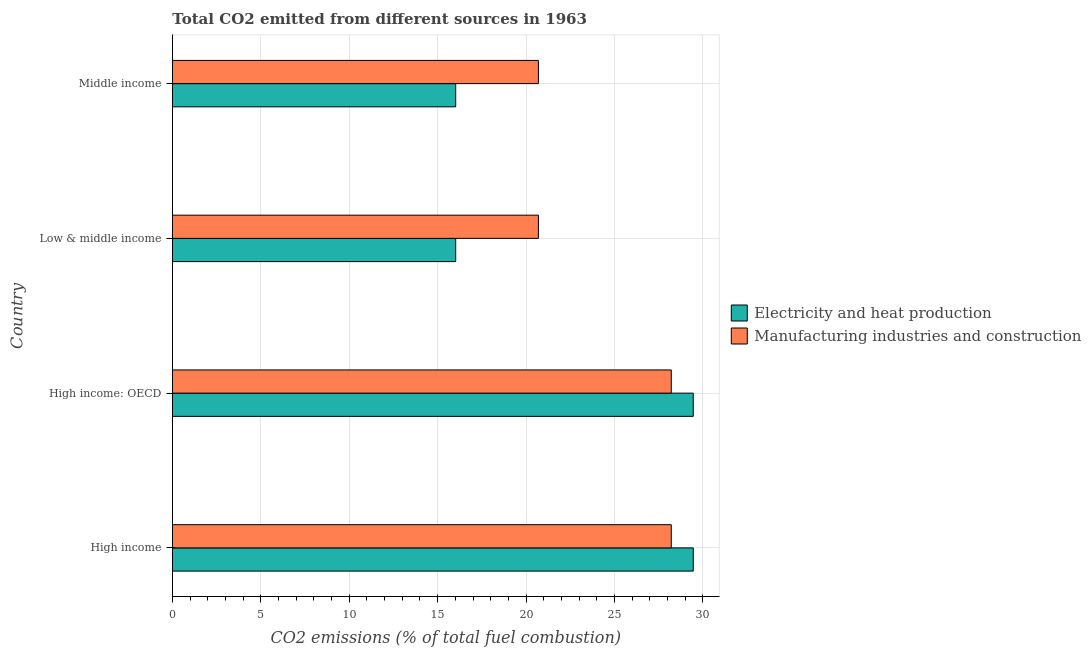How many different coloured bars are there?
Offer a very short reply. 2. How many groups of bars are there?
Your answer should be compact. 4. What is the label of the 1st group of bars from the top?
Ensure brevity in your answer.  Middle income. In how many cases, is the number of bars for a given country not equal to the number of legend labels?
Your answer should be compact. 0. What is the co2 emissions due to electricity and heat production in High income: OECD?
Offer a terse response. 29.45. Across all countries, what is the maximum co2 emissions due to manufacturing industries?
Your answer should be very brief. 28.21. Across all countries, what is the minimum co2 emissions due to electricity and heat production?
Offer a terse response. 16.02. In which country was the co2 emissions due to electricity and heat production maximum?
Provide a short and direct response. High income. What is the total co2 emissions due to manufacturing industries in the graph?
Your answer should be very brief. 97.81. What is the difference between the co2 emissions due to electricity and heat production in High income and that in Middle income?
Offer a terse response. 13.43. What is the difference between the co2 emissions due to manufacturing industries in Middle income and the co2 emissions due to electricity and heat production in Low & middle income?
Make the answer very short. 4.68. What is the average co2 emissions due to electricity and heat production per country?
Give a very brief answer. 22.73. What is the difference between the co2 emissions due to manufacturing industries and co2 emissions due to electricity and heat production in Low & middle income?
Provide a short and direct response. 4.68. What is the ratio of the co2 emissions due to electricity and heat production in High income to that in High income: OECD?
Your answer should be very brief. 1. Is the co2 emissions due to manufacturing industries in High income less than that in Low & middle income?
Offer a terse response. No. Is the difference between the co2 emissions due to electricity and heat production in High income: OECD and Middle income greater than the difference between the co2 emissions due to manufacturing industries in High income: OECD and Middle income?
Ensure brevity in your answer.  Yes. What is the difference between the highest and the second highest co2 emissions due to electricity and heat production?
Your answer should be very brief. 0. What is the difference between the highest and the lowest co2 emissions due to manufacturing industries?
Give a very brief answer. 7.51. In how many countries, is the co2 emissions due to electricity and heat production greater than the average co2 emissions due to electricity and heat production taken over all countries?
Ensure brevity in your answer.  2. What does the 1st bar from the top in Low & middle income represents?
Ensure brevity in your answer.  Manufacturing industries and construction. What does the 2nd bar from the bottom in High income: OECD represents?
Your answer should be compact. Manufacturing industries and construction. How many bars are there?
Make the answer very short. 8. How many countries are there in the graph?
Your response must be concise. 4. Are the values on the major ticks of X-axis written in scientific E-notation?
Your response must be concise. No. Does the graph contain any zero values?
Your response must be concise. No. How are the legend labels stacked?
Your answer should be compact. Vertical. What is the title of the graph?
Your answer should be very brief. Total CO2 emitted from different sources in 1963. What is the label or title of the X-axis?
Your response must be concise. CO2 emissions (% of total fuel combustion). What is the CO2 emissions (% of total fuel combustion) in Electricity and heat production in High income?
Your response must be concise. 29.45. What is the CO2 emissions (% of total fuel combustion) of Manufacturing industries and construction in High income?
Provide a short and direct response. 28.21. What is the CO2 emissions (% of total fuel combustion) of Electricity and heat production in High income: OECD?
Offer a very short reply. 29.45. What is the CO2 emissions (% of total fuel combustion) of Manufacturing industries and construction in High income: OECD?
Offer a terse response. 28.21. What is the CO2 emissions (% of total fuel combustion) in Electricity and heat production in Low & middle income?
Offer a very short reply. 16.02. What is the CO2 emissions (% of total fuel combustion) in Manufacturing industries and construction in Low & middle income?
Offer a very short reply. 20.7. What is the CO2 emissions (% of total fuel combustion) in Electricity and heat production in Middle income?
Your answer should be very brief. 16.02. What is the CO2 emissions (% of total fuel combustion) in Manufacturing industries and construction in Middle income?
Your response must be concise. 20.7. Across all countries, what is the maximum CO2 emissions (% of total fuel combustion) of Electricity and heat production?
Keep it short and to the point. 29.45. Across all countries, what is the maximum CO2 emissions (% of total fuel combustion) of Manufacturing industries and construction?
Provide a short and direct response. 28.21. Across all countries, what is the minimum CO2 emissions (% of total fuel combustion) of Electricity and heat production?
Provide a short and direct response. 16.02. Across all countries, what is the minimum CO2 emissions (% of total fuel combustion) in Manufacturing industries and construction?
Provide a succinct answer. 20.7. What is the total CO2 emissions (% of total fuel combustion) in Electricity and heat production in the graph?
Give a very brief answer. 90.94. What is the total CO2 emissions (% of total fuel combustion) of Manufacturing industries and construction in the graph?
Your response must be concise. 97.81. What is the difference between the CO2 emissions (% of total fuel combustion) in Electricity and heat production in High income and that in High income: OECD?
Ensure brevity in your answer.  0. What is the difference between the CO2 emissions (% of total fuel combustion) in Electricity and heat production in High income and that in Low & middle income?
Provide a short and direct response. 13.43. What is the difference between the CO2 emissions (% of total fuel combustion) in Manufacturing industries and construction in High income and that in Low & middle income?
Ensure brevity in your answer.  7.51. What is the difference between the CO2 emissions (% of total fuel combustion) in Electricity and heat production in High income and that in Middle income?
Provide a succinct answer. 13.43. What is the difference between the CO2 emissions (% of total fuel combustion) of Manufacturing industries and construction in High income and that in Middle income?
Keep it short and to the point. 7.51. What is the difference between the CO2 emissions (% of total fuel combustion) in Electricity and heat production in High income: OECD and that in Low & middle income?
Your answer should be compact. 13.43. What is the difference between the CO2 emissions (% of total fuel combustion) in Manufacturing industries and construction in High income: OECD and that in Low & middle income?
Make the answer very short. 7.51. What is the difference between the CO2 emissions (% of total fuel combustion) in Electricity and heat production in High income: OECD and that in Middle income?
Your answer should be very brief. 13.43. What is the difference between the CO2 emissions (% of total fuel combustion) in Manufacturing industries and construction in High income: OECD and that in Middle income?
Keep it short and to the point. 7.51. What is the difference between the CO2 emissions (% of total fuel combustion) in Manufacturing industries and construction in Low & middle income and that in Middle income?
Provide a succinct answer. 0. What is the difference between the CO2 emissions (% of total fuel combustion) of Electricity and heat production in High income and the CO2 emissions (% of total fuel combustion) of Manufacturing industries and construction in High income: OECD?
Ensure brevity in your answer.  1.24. What is the difference between the CO2 emissions (% of total fuel combustion) in Electricity and heat production in High income and the CO2 emissions (% of total fuel combustion) in Manufacturing industries and construction in Low & middle income?
Make the answer very short. 8.75. What is the difference between the CO2 emissions (% of total fuel combustion) in Electricity and heat production in High income and the CO2 emissions (% of total fuel combustion) in Manufacturing industries and construction in Middle income?
Keep it short and to the point. 8.75. What is the difference between the CO2 emissions (% of total fuel combustion) in Electricity and heat production in High income: OECD and the CO2 emissions (% of total fuel combustion) in Manufacturing industries and construction in Low & middle income?
Give a very brief answer. 8.75. What is the difference between the CO2 emissions (% of total fuel combustion) of Electricity and heat production in High income: OECD and the CO2 emissions (% of total fuel combustion) of Manufacturing industries and construction in Middle income?
Your answer should be very brief. 8.75. What is the difference between the CO2 emissions (% of total fuel combustion) in Electricity and heat production in Low & middle income and the CO2 emissions (% of total fuel combustion) in Manufacturing industries and construction in Middle income?
Give a very brief answer. -4.68. What is the average CO2 emissions (% of total fuel combustion) in Electricity and heat production per country?
Offer a very short reply. 22.74. What is the average CO2 emissions (% of total fuel combustion) in Manufacturing industries and construction per country?
Offer a very short reply. 24.45. What is the difference between the CO2 emissions (% of total fuel combustion) in Electricity and heat production and CO2 emissions (% of total fuel combustion) in Manufacturing industries and construction in High income?
Provide a succinct answer. 1.24. What is the difference between the CO2 emissions (% of total fuel combustion) of Electricity and heat production and CO2 emissions (% of total fuel combustion) of Manufacturing industries and construction in High income: OECD?
Make the answer very short. 1.24. What is the difference between the CO2 emissions (% of total fuel combustion) in Electricity and heat production and CO2 emissions (% of total fuel combustion) in Manufacturing industries and construction in Low & middle income?
Keep it short and to the point. -4.68. What is the difference between the CO2 emissions (% of total fuel combustion) in Electricity and heat production and CO2 emissions (% of total fuel combustion) in Manufacturing industries and construction in Middle income?
Your response must be concise. -4.68. What is the ratio of the CO2 emissions (% of total fuel combustion) of Manufacturing industries and construction in High income to that in High income: OECD?
Give a very brief answer. 1. What is the ratio of the CO2 emissions (% of total fuel combustion) of Electricity and heat production in High income to that in Low & middle income?
Your response must be concise. 1.84. What is the ratio of the CO2 emissions (% of total fuel combustion) in Manufacturing industries and construction in High income to that in Low & middle income?
Provide a succinct answer. 1.36. What is the ratio of the CO2 emissions (% of total fuel combustion) in Electricity and heat production in High income to that in Middle income?
Your answer should be compact. 1.84. What is the ratio of the CO2 emissions (% of total fuel combustion) in Manufacturing industries and construction in High income to that in Middle income?
Your answer should be compact. 1.36. What is the ratio of the CO2 emissions (% of total fuel combustion) in Electricity and heat production in High income: OECD to that in Low & middle income?
Your response must be concise. 1.84. What is the ratio of the CO2 emissions (% of total fuel combustion) in Manufacturing industries and construction in High income: OECD to that in Low & middle income?
Your answer should be very brief. 1.36. What is the ratio of the CO2 emissions (% of total fuel combustion) of Electricity and heat production in High income: OECD to that in Middle income?
Provide a short and direct response. 1.84. What is the ratio of the CO2 emissions (% of total fuel combustion) in Manufacturing industries and construction in High income: OECD to that in Middle income?
Keep it short and to the point. 1.36. What is the difference between the highest and the second highest CO2 emissions (% of total fuel combustion) in Manufacturing industries and construction?
Ensure brevity in your answer.  0. What is the difference between the highest and the lowest CO2 emissions (% of total fuel combustion) of Electricity and heat production?
Provide a succinct answer. 13.43. What is the difference between the highest and the lowest CO2 emissions (% of total fuel combustion) in Manufacturing industries and construction?
Give a very brief answer. 7.51. 